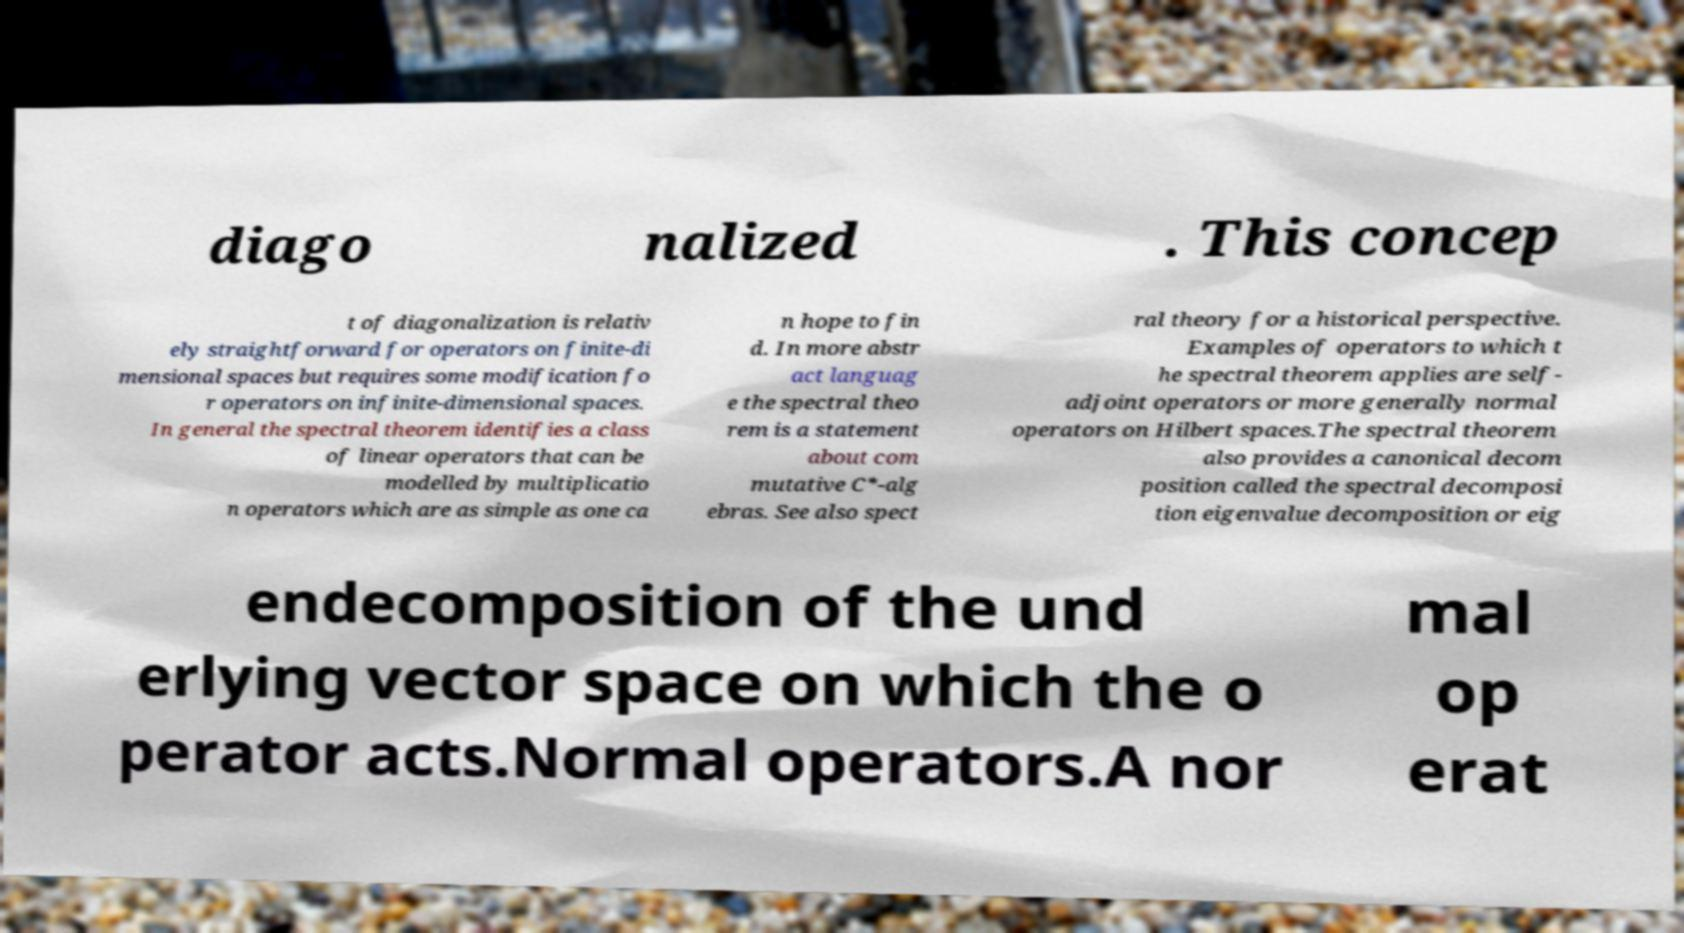Please read and relay the text visible in this image. What does it say? diago nalized . This concep t of diagonalization is relativ ely straightforward for operators on finite-di mensional spaces but requires some modification fo r operators on infinite-dimensional spaces. In general the spectral theorem identifies a class of linear operators that can be modelled by multiplicatio n operators which are as simple as one ca n hope to fin d. In more abstr act languag e the spectral theo rem is a statement about com mutative C*-alg ebras. See also spect ral theory for a historical perspective. Examples of operators to which t he spectral theorem applies are self- adjoint operators or more generally normal operators on Hilbert spaces.The spectral theorem also provides a canonical decom position called the spectral decomposi tion eigenvalue decomposition or eig endecomposition of the und erlying vector space on which the o perator acts.Normal operators.A nor mal op erat 